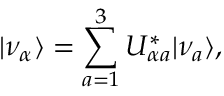Convert formula to latex. <formula><loc_0><loc_0><loc_500><loc_500>| \nu _ { \alpha } \rangle = \sum _ { a = 1 } ^ { 3 } U _ { \alpha a } ^ { \ast } | \nu _ { a } \rangle ,</formula> 